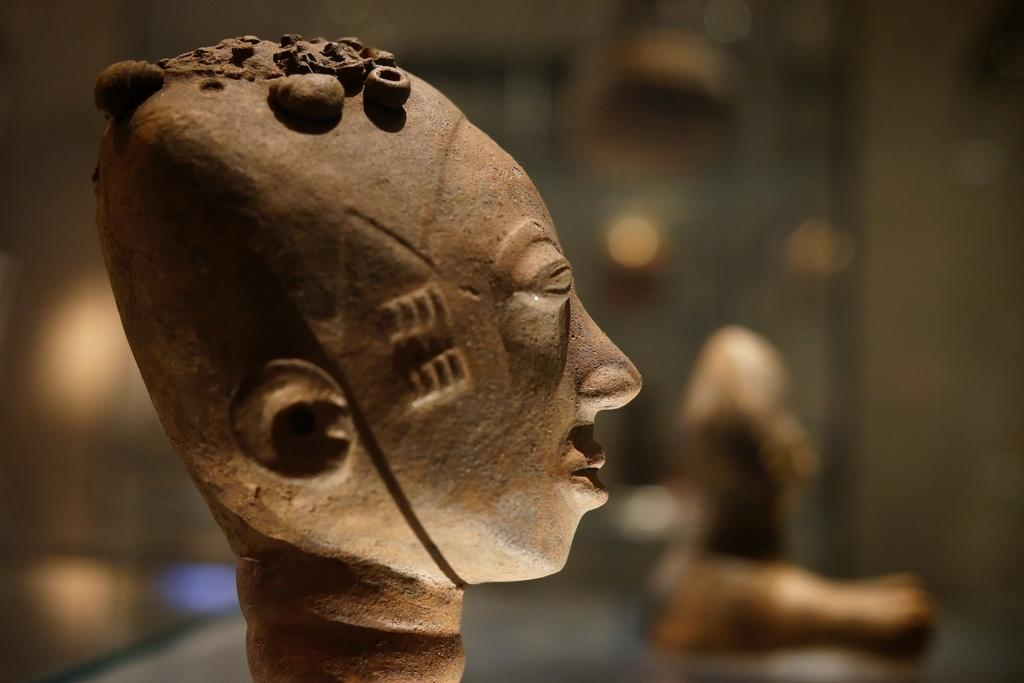What is the main subject of the image? The main subject of the image is a carved stone. What can be said about the color of the carved stone? The carved stone is brown in color. Can you see any powder on the carved stone in the image? There is no mention of powder in the image, so it cannot be determined if any is present. 